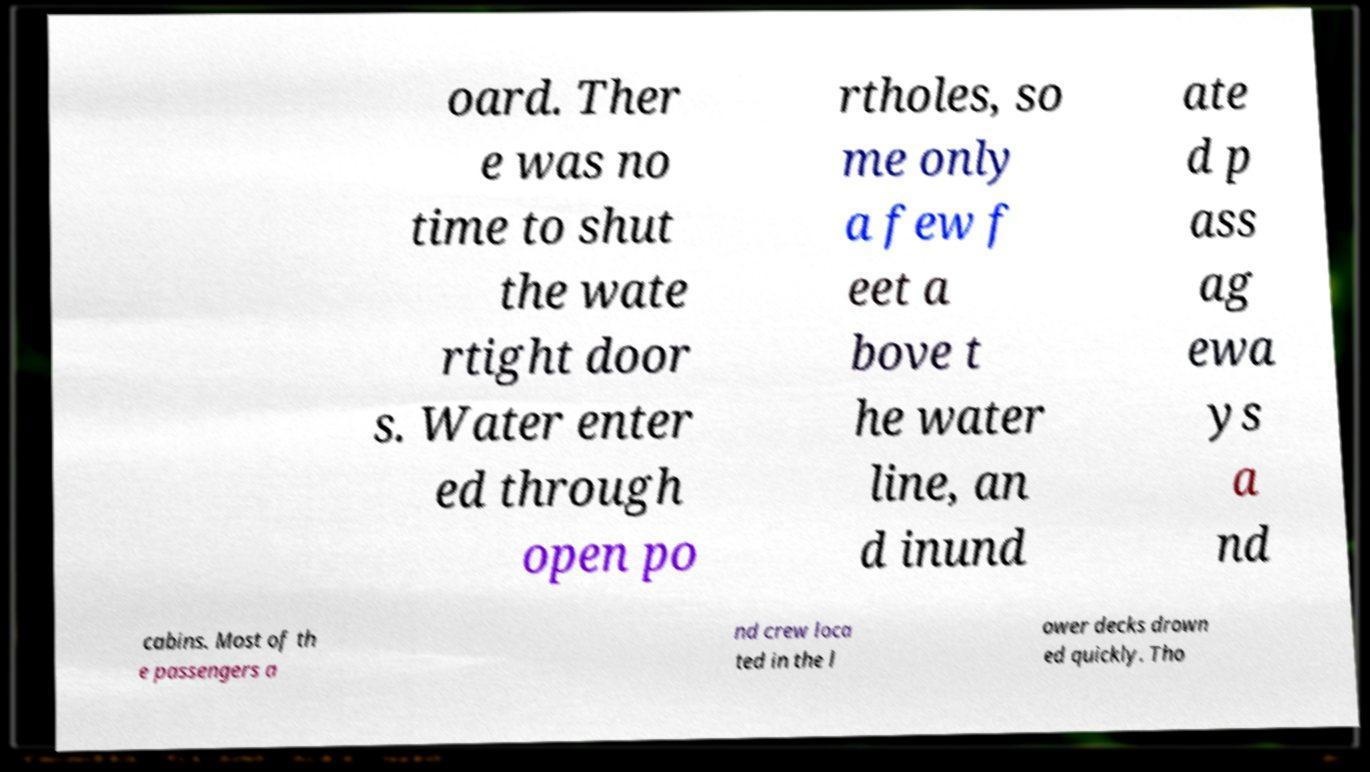What messages or text are displayed in this image? I need them in a readable, typed format. oard. Ther e was no time to shut the wate rtight door s. Water enter ed through open po rtholes, so me only a few f eet a bove t he water line, an d inund ate d p ass ag ewa ys a nd cabins. Most of th e passengers a nd crew loca ted in the l ower decks drown ed quickly. Tho 